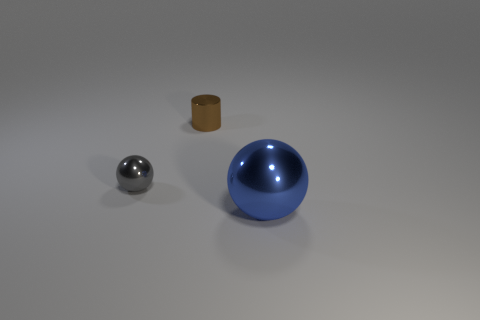What is the cylinder made of?
Make the answer very short. Metal. There is a metal thing to the left of the brown cylinder; is it the same shape as the blue metal thing?
Provide a short and direct response. Yes. What number of things are large brown shiny blocks or spheres?
Offer a very short reply. 2. Is the material of the object that is behind the tiny shiny ball the same as the gray sphere?
Your response must be concise. Yes. The blue shiny ball is what size?
Keep it short and to the point. Large. How many cubes are brown things or gray metal objects?
Offer a terse response. 0. Is the number of blue spheres that are in front of the big blue metal ball the same as the number of gray spheres right of the small brown metal thing?
Offer a very short reply. Yes. There is a blue object that is the same shape as the gray thing; what size is it?
Make the answer very short. Large. What size is the thing that is both in front of the brown thing and on the left side of the big metal sphere?
Ensure brevity in your answer.  Small. Are there any tiny brown cylinders in front of the gray metallic sphere?
Your answer should be compact. No. 